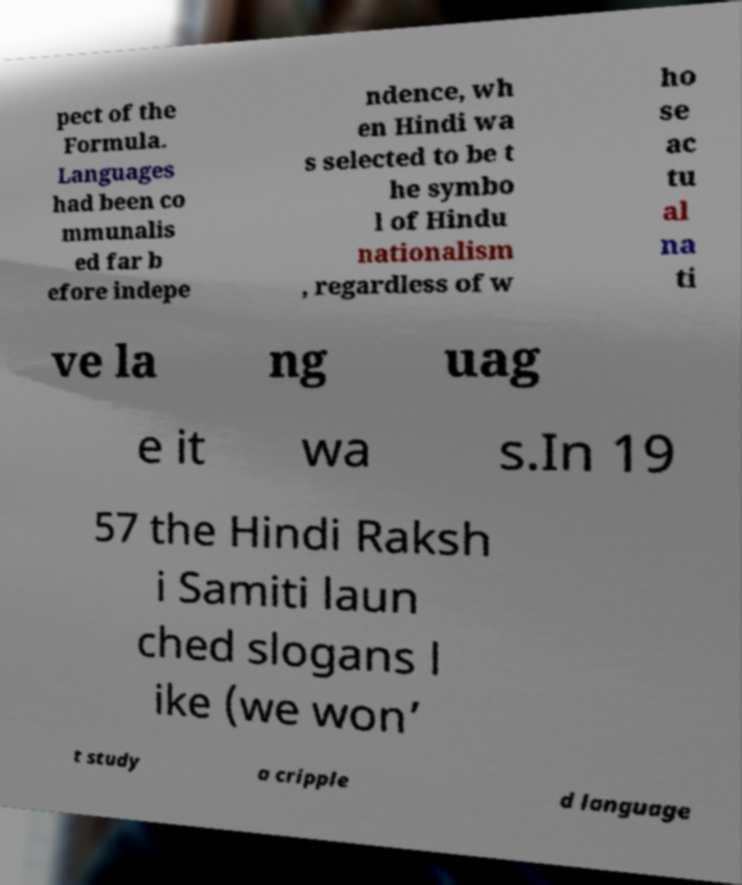Can you read and provide the text displayed in the image?This photo seems to have some interesting text. Can you extract and type it out for me? pect of the Formula. Languages had been co mmunalis ed far b efore indepe ndence, wh en Hindi wa s selected to be t he symbo l of Hindu nationalism , regardless of w ho se ac tu al na ti ve la ng uag e it wa s.In 19 57 the Hindi Raksh i Samiti laun ched slogans l ike (we won’ t study a cripple d language 